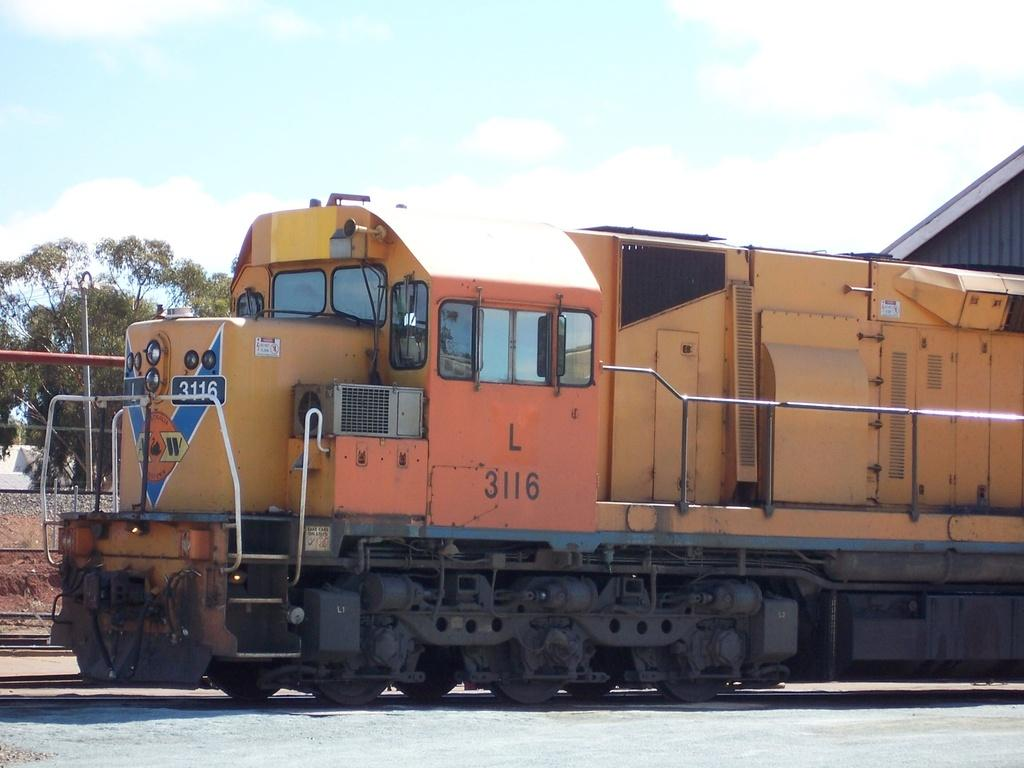What is the main subject of the image? The main subject of the image is a train. Where is the train located in the image? The train is on a track. What type of vegetation can be seen in the image? There is a tree visible in the image. What type of structure is partially visible in the image? The roof of a house is visible in the image. What is the condition of the sky in the image? The sky is visible in the image and appears cloudy. What type of wool is being used to create a wall in the image? There is no wool or wall present in the image; it features a train on a track with a tree, a roof of a house, and a cloudy sky. 